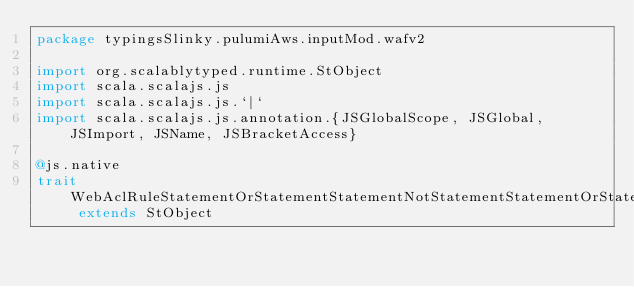<code> <loc_0><loc_0><loc_500><loc_500><_Scala_>package typingsSlinky.pulumiAws.inputMod.wafv2

import org.scalablytyped.runtime.StObject
import scala.scalajs.js
import scala.scalajs.js.`|`
import scala.scalajs.js.annotation.{JSGlobalScope, JSGlobal, JSImport, JSName, JSBracketAccess}

@js.native
trait WebAclRuleStatementOrStatementStatementNotStatementStatementOrStatementStatementSqliMatchStatementFieldToMatchUriPath extends StObject
</code> 